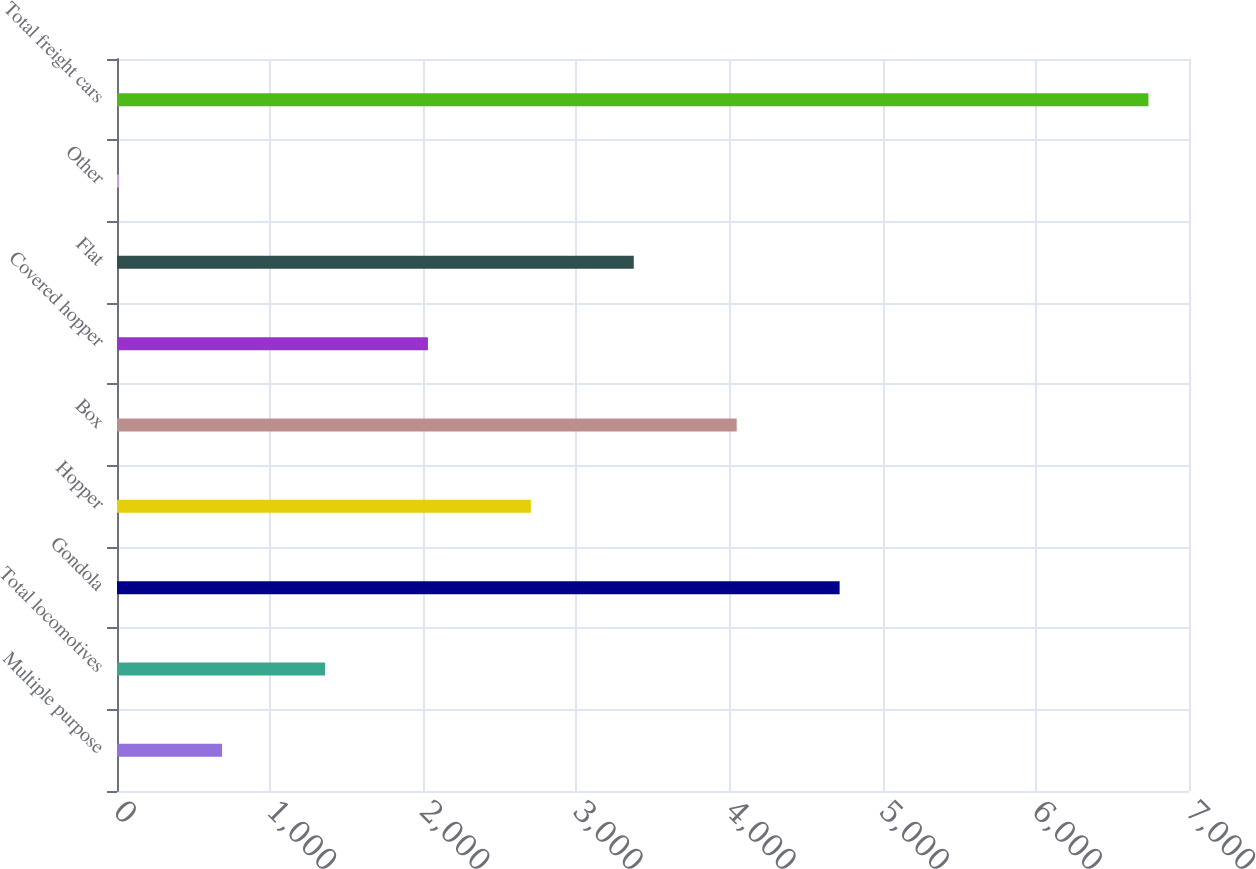Convert chart to OTSL. <chart><loc_0><loc_0><loc_500><loc_500><bar_chart><fcel>Multiple purpose<fcel>Total locomotives<fcel>Gondola<fcel>Hopper<fcel>Box<fcel>Covered hopper<fcel>Flat<fcel>Other<fcel>Total freight cars<nl><fcel>686.1<fcel>1358.2<fcel>4718.7<fcel>2702.4<fcel>4046.6<fcel>2030.3<fcel>3374.5<fcel>14<fcel>6735<nl></chart> 